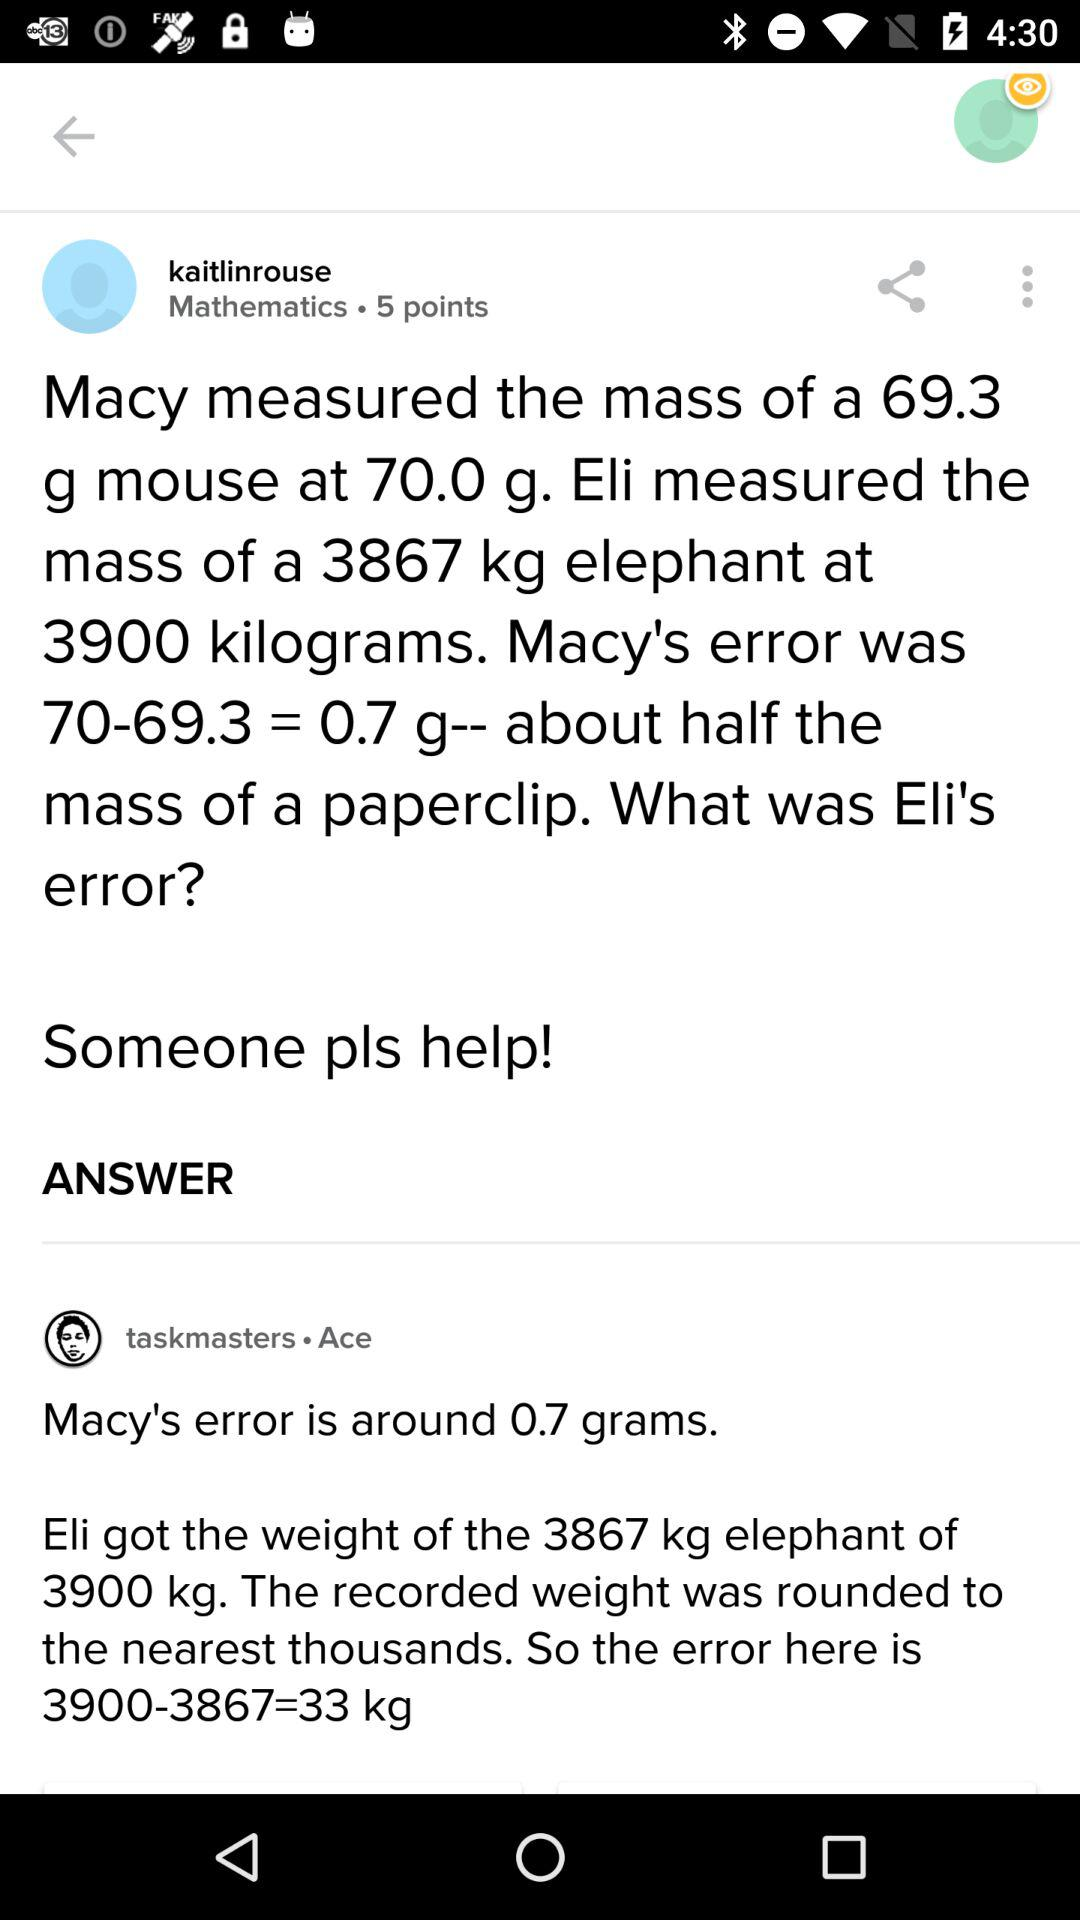What was the total amount of error in the measurements?
Answer the question using a single word or phrase. 33.7 